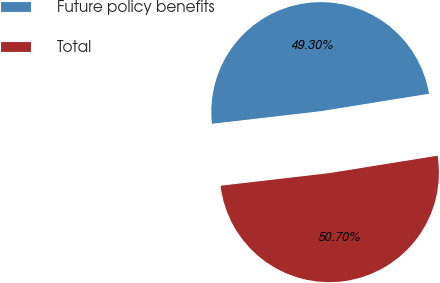Convert chart. <chart><loc_0><loc_0><loc_500><loc_500><pie_chart><fcel>Future policy benefits<fcel>Total<nl><fcel>49.3%<fcel>50.7%<nl></chart> 